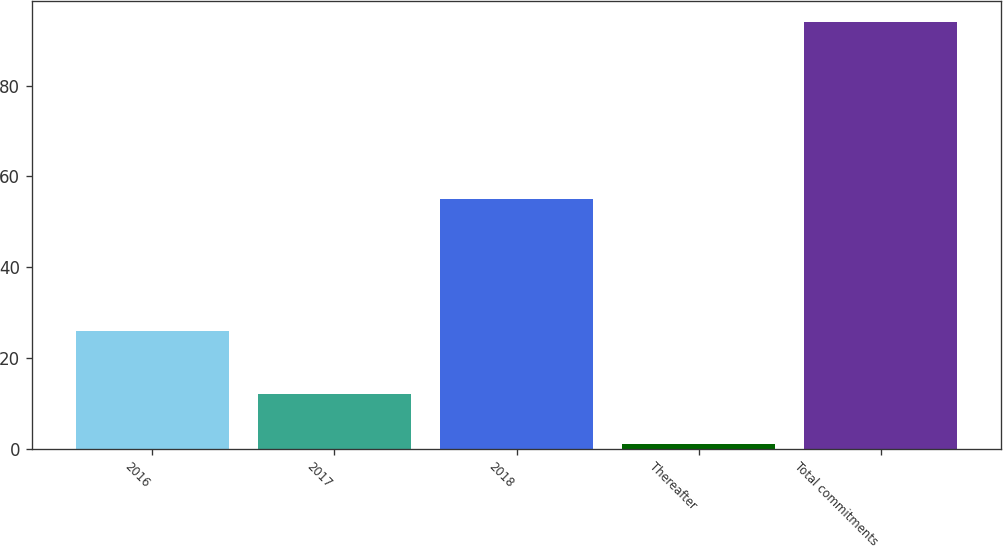<chart> <loc_0><loc_0><loc_500><loc_500><bar_chart><fcel>2016<fcel>2017<fcel>2018<fcel>Thereafter<fcel>Total commitments<nl><fcel>26<fcel>12<fcel>55<fcel>1<fcel>94<nl></chart> 